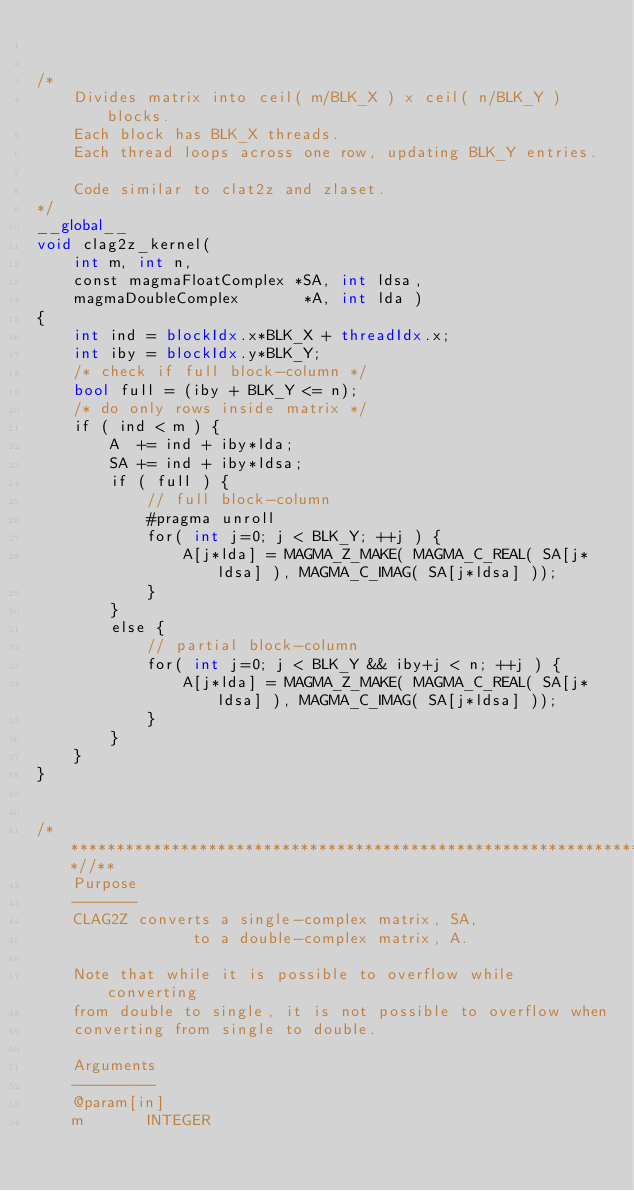Convert code to text. <code><loc_0><loc_0><loc_500><loc_500><_Cuda_>

/*
    Divides matrix into ceil( m/BLK_X ) x ceil( n/BLK_Y ) blocks.
    Each block has BLK_X threads.
    Each thread loops across one row, updating BLK_Y entries.
    
    Code similar to clat2z and zlaset.
*/
__global__
void clag2z_kernel(
    int m, int n,
    const magmaFloatComplex *SA, int ldsa,
    magmaDoubleComplex       *A, int lda )
{
    int ind = blockIdx.x*BLK_X + threadIdx.x;
    int iby = blockIdx.y*BLK_Y;
    /* check if full block-column */
    bool full = (iby + BLK_Y <= n);
    /* do only rows inside matrix */
    if ( ind < m ) {
        A  += ind + iby*lda;
        SA += ind + iby*ldsa;
        if ( full ) {
            // full block-column
            #pragma unroll
            for( int j=0; j < BLK_Y; ++j ) {
                A[j*lda] = MAGMA_Z_MAKE( MAGMA_C_REAL( SA[j*ldsa] ), MAGMA_C_IMAG( SA[j*ldsa] ));
            }
        }
        else {
            // partial block-column
            for( int j=0; j < BLK_Y && iby+j < n; ++j ) {
                A[j*lda] = MAGMA_Z_MAKE( MAGMA_C_REAL( SA[j*ldsa] ), MAGMA_C_IMAG( SA[j*ldsa] ));
            }
        }
    }
}


/***************************************************************************//**
    Purpose
    -------
    CLAG2Z converts a single-complex matrix, SA,
                 to a double-complex matrix, A.

    Note that while it is possible to overflow while converting
    from double to single, it is not possible to overflow when
    converting from single to double.

    Arguments
    ---------
    @param[in]
    m       INTEGER</code> 